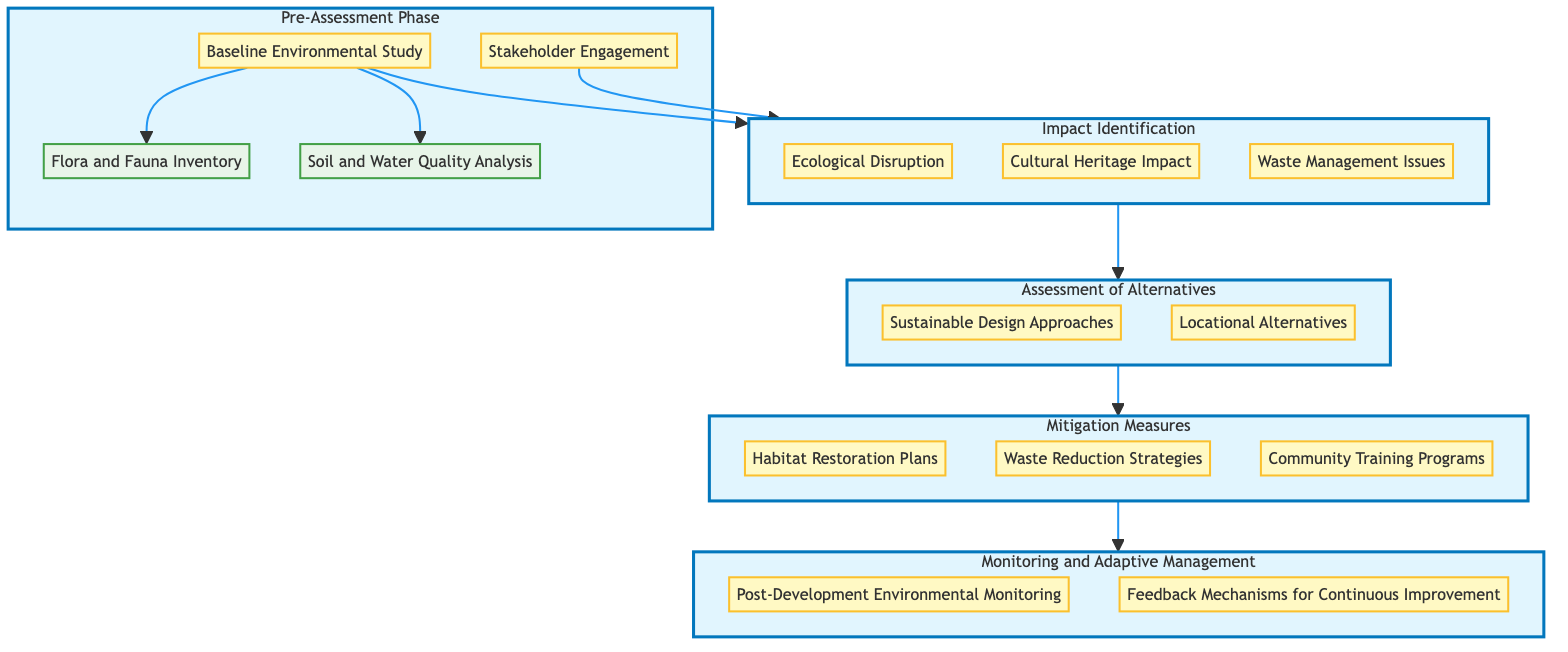What is the first phase in the flow chart? The first phase in the flow chart is identified in the "Pre-Assessment Phase" node at the top of the diagram. This is the starting point of the process leading to the subsequent phases.
Answer: Pre-Assessment Phase How many sub-elements are under the Impact Identification phase? In the "Impact Identification" phase, there are three sub-elements: "Ecological Disruption", "Cultural Heritage Impact", and "Waste Management Issues". Therefore, by counting them, we see there are three sub-elements total.
Answer: 3 What follows the Mitigation Measures phase? The "Monitoring and Adaptive Management" phase directly follows the "Mitigation Measures" phase as indicated by the arrows connecting them within the flow chart. This shows the progression of the assessment process.
Answer: Monitoring and Adaptive Management What is a key area of concern in the Impact Identification phase? One of the key areas of concern listed in the "Impact Identification" phase is "Waste Management Issues", which is one of the sub-elements among others.
Answer: Waste Management Issues Which sub-element comes under the Baseline Environmental Study? The "Baseline Environmental Study" has two sub-elements listed beneath it: "Flora and Fauna Inventory" and "Soil and Water Quality Analysis". Therefore, either of these could be chosen as an answer; hence, I will take the first as an example.
Answer: Flora and Fauna Inventory How are the nodes connected in a bottom-up manner? The diagram's structure represents a bottom-up flow where each phase is sequentially linked starting from the "Pre-Assessment Phase" down to "Monitoring and Adaptive Management". This means each sub-element is connected to the upper phase, leading to the next in line.
Answer: Sequentially connected from bottom to top What does the flow of information depict? The flow of information in this diagram depicts the process of conducting Environmental Impact Assessments, moving from stakeholder engagement through assessments of impacts to conducting monitoring after mitigation measures are implemented. This shows a comprehensive approach to the assessments.
Answer: Comprehensive assessment process What does the term "Adaptive Management" refer to in this context? "Adaptive Management" in this context refers to the ongoing process of adjusting management strategies based on feedback and monitoring outcomes post-development, aiming for continual improvement in sustainability practices.
Answer: Ongoing management adjustments How are stakeholder inputs integrated into the assessment process? Stakeholder inputs are integrated in the initial "Stakeholder Engagement" phase, which is the first step in the assessment process. Their engagement is crucial before identifying impacts and planning alternatives.
Answer: Initial engagement step What are the types of strategies listed under Mitigation Measures? The sub-elements under Mitigation Measures include "Habitat Restoration Plans", "Waste Reduction Strategies", and "Community Training Programs", showcasing different approaches to mitigate environmental impacts effectively.
Answer: Habitat Restoration Plans, Waste Reduction Strategies, Community Training Programs 